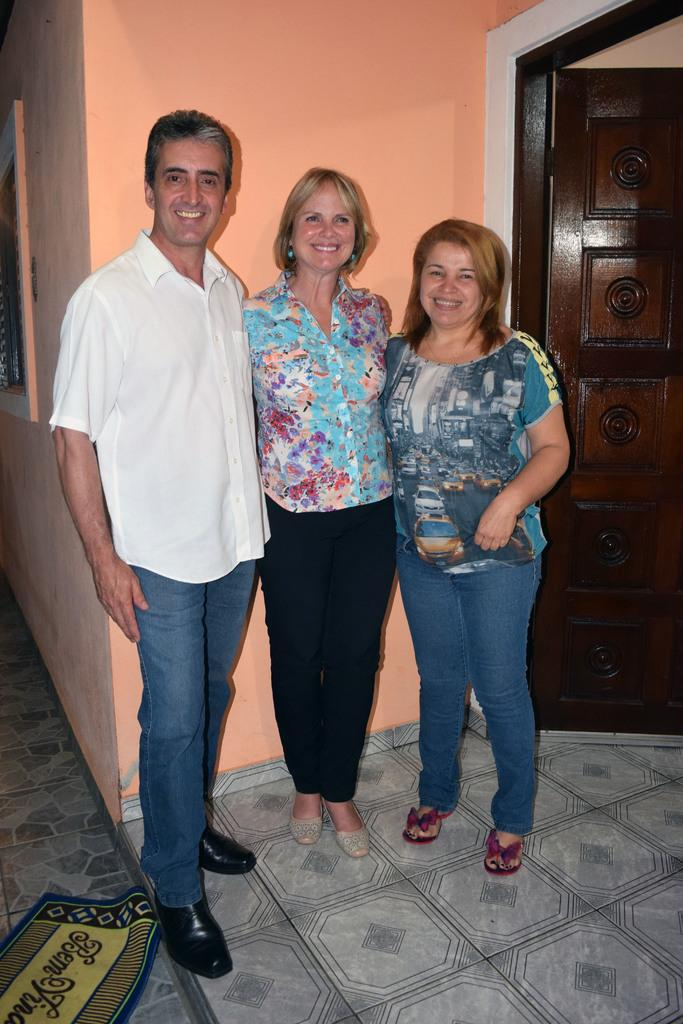How many people are in the image? There is a man and two women in the image, making a total of three people. What are the people doing in the image? The people are standing on the floor. What can be seen on the floor in the image? There is a doormat on the floor. What is visible in the background of the image? There is a wall, a window, and a door in the background of the image. Where is the basin located in the image? There is no basin present in the image. Can you tell me how many trays are being used by the people in the image? There is no tray visible in the image; the people are simply standing on the floor. 